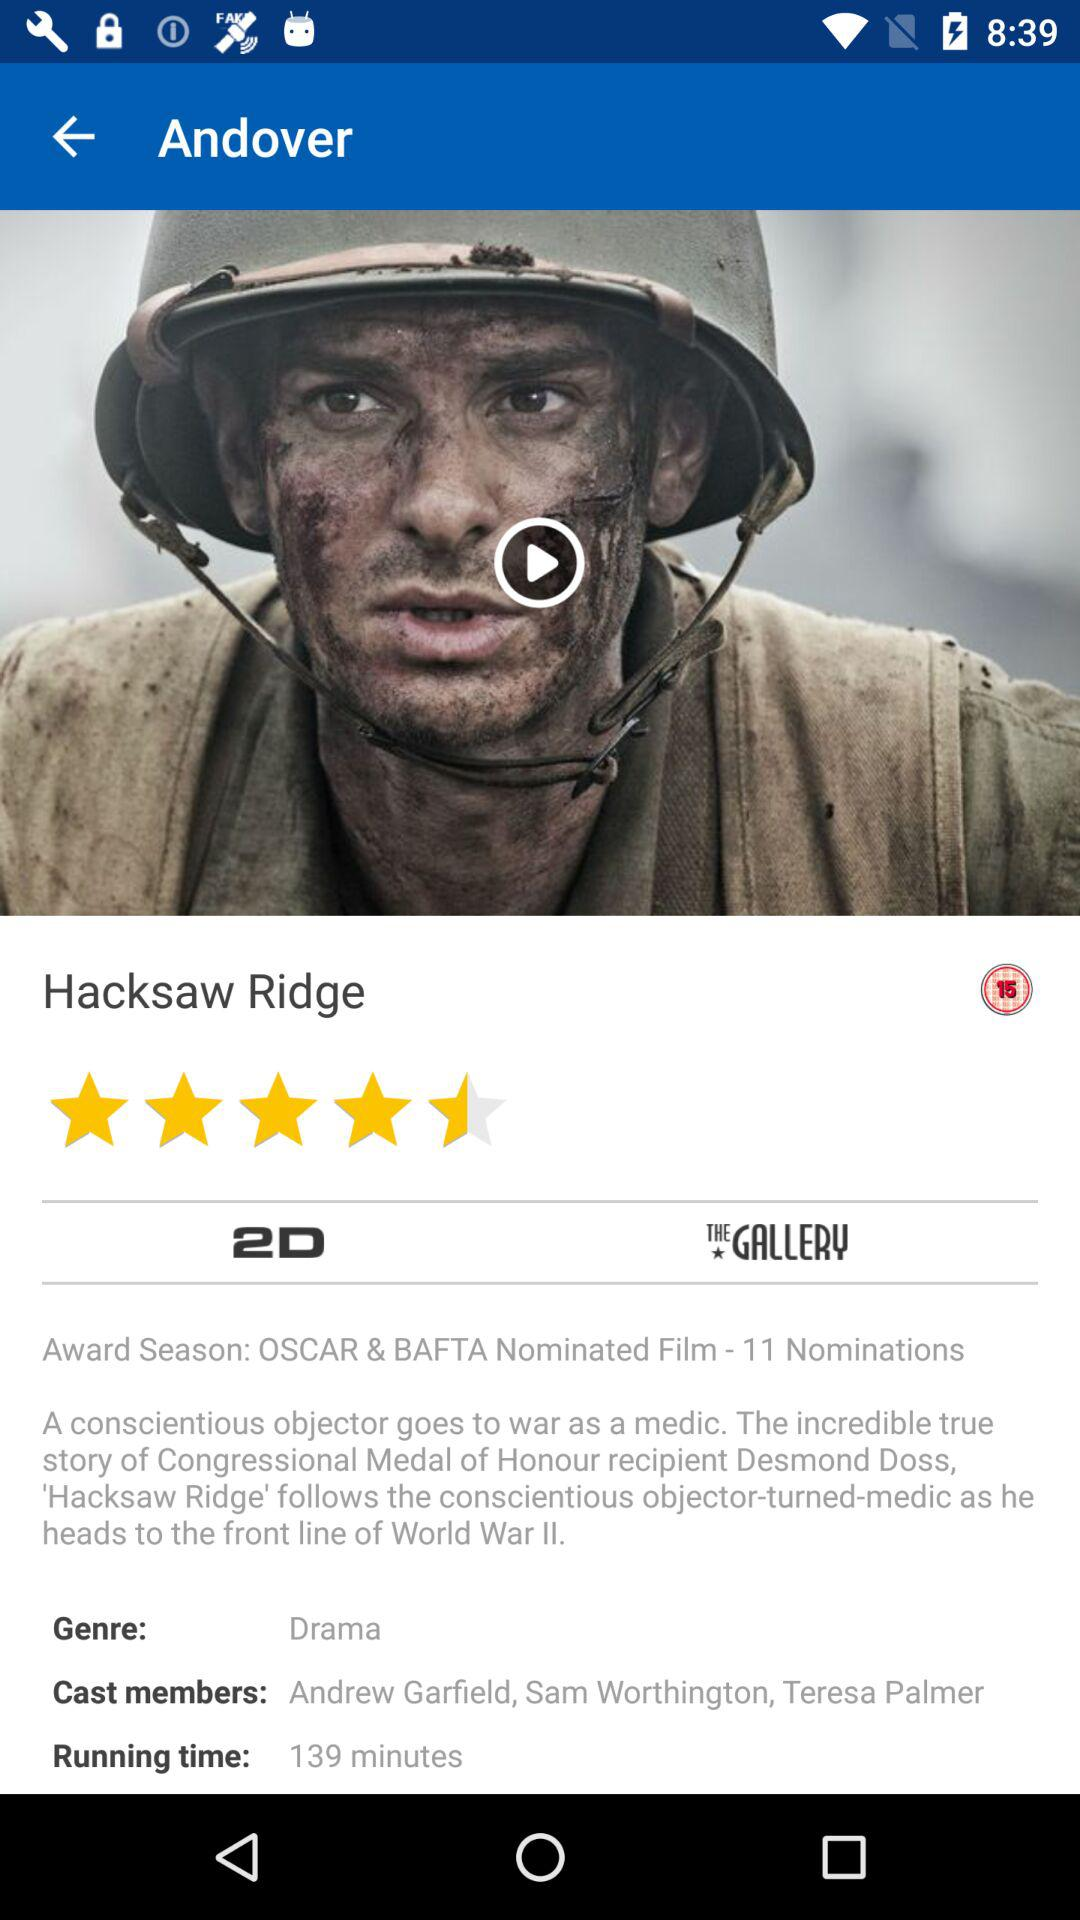What is the name of the movie? The name of the movie is "Hacksaw Ridge". 